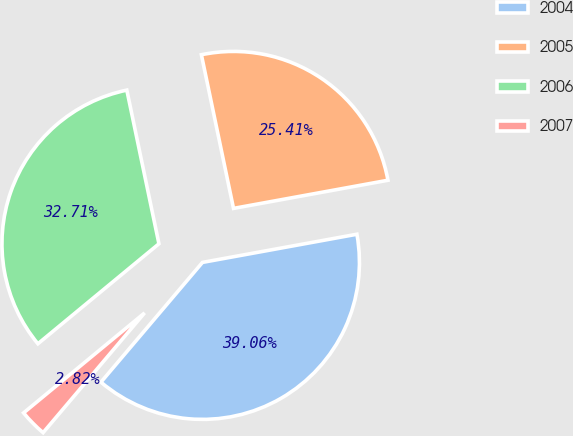Convert chart. <chart><loc_0><loc_0><loc_500><loc_500><pie_chart><fcel>2004<fcel>2005<fcel>2006<fcel>2007<nl><fcel>39.06%<fcel>25.41%<fcel>32.71%<fcel>2.82%<nl></chart> 